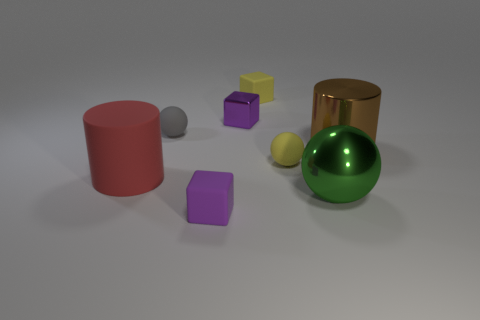Which object in the image is the largest? The largest object in the image is the red cylinder. It stands out due to its height and solid color, making it a prominent figure against the subdued background. 